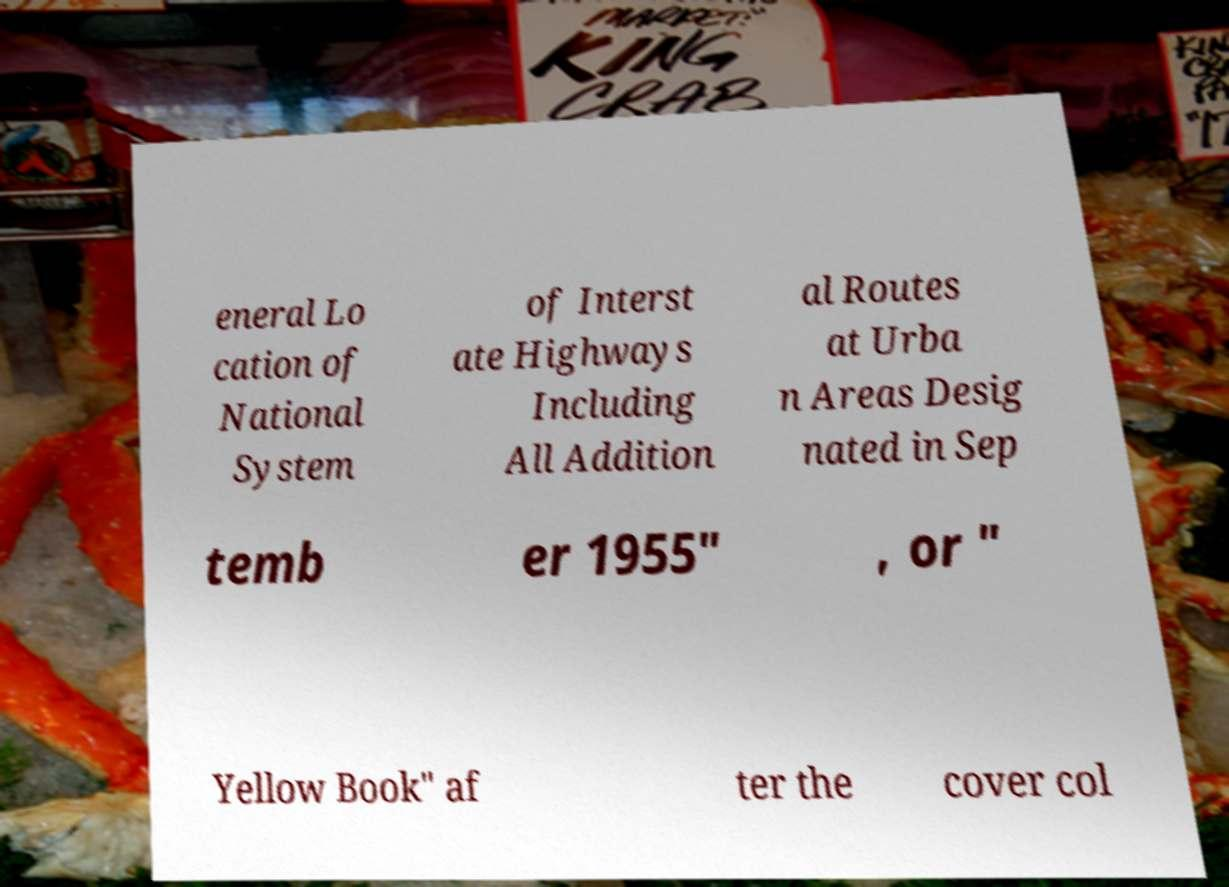What messages or text are displayed in this image? I need them in a readable, typed format. eneral Lo cation of National System of Interst ate Highways Including All Addition al Routes at Urba n Areas Desig nated in Sep temb er 1955" , or " Yellow Book" af ter the cover col 